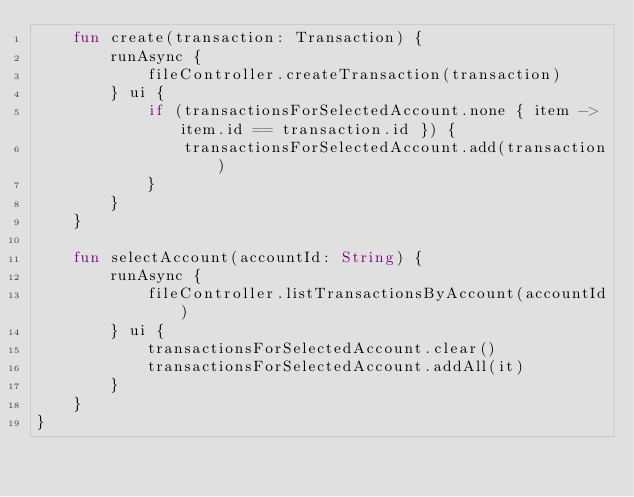Convert code to text. <code><loc_0><loc_0><loc_500><loc_500><_Kotlin_>    fun create(transaction: Transaction) {
        runAsync {
            fileController.createTransaction(transaction)
        } ui {
            if (transactionsForSelectedAccount.none { item -> item.id == transaction.id }) {
                transactionsForSelectedAccount.add(transaction)
            }
        }
    }

    fun selectAccount(accountId: String) {
        runAsync {
            fileController.listTransactionsByAccount(accountId)
        } ui {
            transactionsForSelectedAccount.clear()
            transactionsForSelectedAccount.addAll(it)
        }
    }
}
</code> 